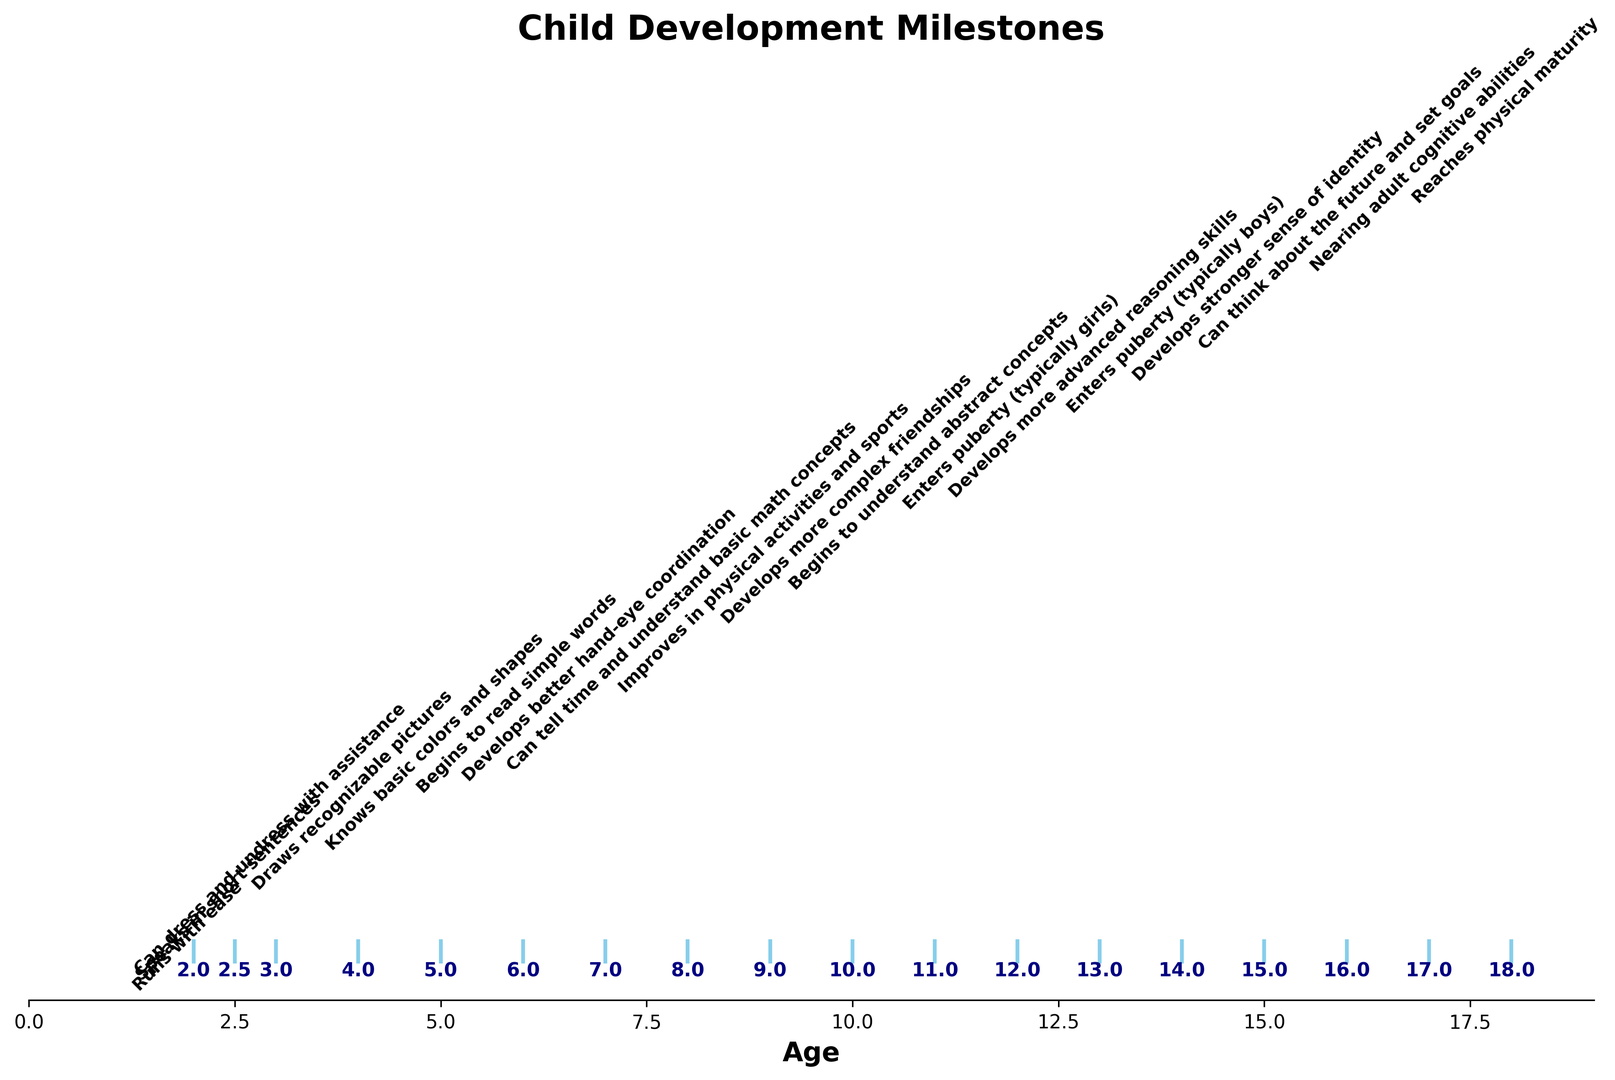Which milestone occurs at age 6? The timeline shows milestones along with corresponding ages. At age 6, "Begins to read simple words" appears directly above the number 6.
Answer: Begins to read simple words How many years after children start speaking in short sentences do they typically enter puberty (girls)? Identify the age for speaking in short sentences (2.5 years) and the age for girls entering puberty (12 years). Subtract 2.5 from 12.
Answer: 9.5 years Which milestone occurs first, understanding basic math concepts or developing better hand-eye coordination? Find the ages at which both milestones occur (math concepts at 8 years, hand-eye coordination at 7 years). Compare the ages.
Answer: Developing better hand-eye coordination At what age do children typically develop a stronger sense of identity, and what milestone occurs two years earlier? Find the age for a stronger sense of identity (15 years) and look two years earlier (13 years) for another milestone.
Answer: More advanced reasoning skills Count the number of milestones listed before age 10. Identify and count all milestones occurring at ages less than 10: (Runs with ease, Speaks in short sentences, Can dress and undress with assistance, Draws recognizable pictures, Knows basic colors and shapes, Begins to read simple words, Develops better hand-eye coordination, Can tell time and understand basic math concepts).
Answer: 8 milestones Which age shows the highest concentration of milestones? Observe the plot to find ages where milestones are densely packed.
Answer: 2 years Identify the milestone listed at age 11 and determine if this milestone occurs before boys typically enter puberty. Locate the milestone at age 11 ("Begins to understand abstract concepts"), and compare this with boys entering puberty at age 14. Abstract concepts understanding occurs before puberty in boys.
Answer: Yes, it occurs before Describe the color and overall layout used to visualize the milestones in the plot. The plot uses sky-blue lines (with horizontal orientation) to indicate milestones. Text annotations appear next to age markers, and the overall layout is horizontal with ages on the x-axis.
Answer: Sky-blue, horizontal Is there a milestone indicating physical maturity, and if so, at what age does it occur? Scan the milestones for any note on physical maturity and identify the age listed for it ("Reaches physical maturity" at age 18).
Answer: 18 years Which milestone is linked with age 9, and can it be said to relate to physical development? Locate the milestone at age 9 ("Improves in physical activities and sports") and determine its association with physical development.
Answer: Yes, it relates to physical development 